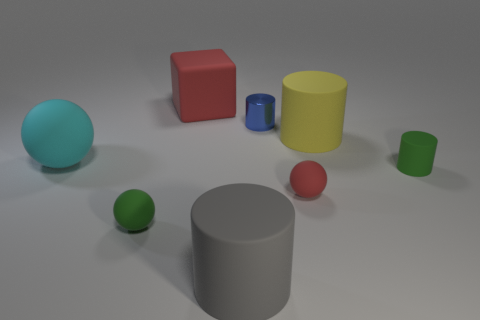Subtract all tiny red rubber spheres. How many spheres are left? 2 Add 1 tiny green matte cylinders. How many objects exist? 9 Subtract 2 cylinders. How many cylinders are left? 2 Subtract all cyan spheres. How many spheres are left? 2 Subtract all brown cylinders. How many gray balls are left? 0 Subtract all big red rubber things. Subtract all cylinders. How many objects are left? 3 Add 1 tiny red rubber things. How many tiny red rubber things are left? 2 Add 6 small purple cylinders. How many small purple cylinders exist? 6 Subtract 0 brown blocks. How many objects are left? 8 Subtract all spheres. How many objects are left? 5 